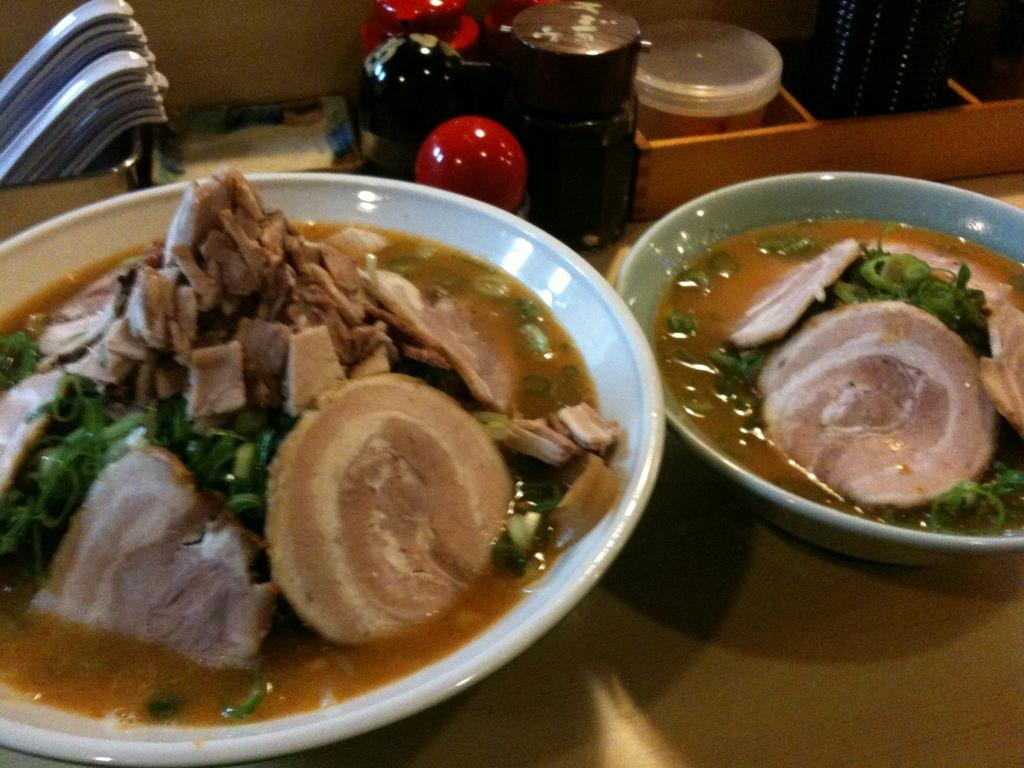What is in the bowls that are visible in the image? There is food in the bowls in the image. What type of containers can be seen in the image? There are bottles in the image. What type of container is not mentioned in the image? There is no mention of a box in the image, although there is a box mentioned in the facts. What type of dishware is visible in the image? There is a plate in the image. What other objects are present in the image? There are additional objects on a platform in the image. Can you see any snails crawling on the food in the image? There are no snails present in the image. What type of transportation is available at the airport in the image? There is no mention of an airport in the image. 